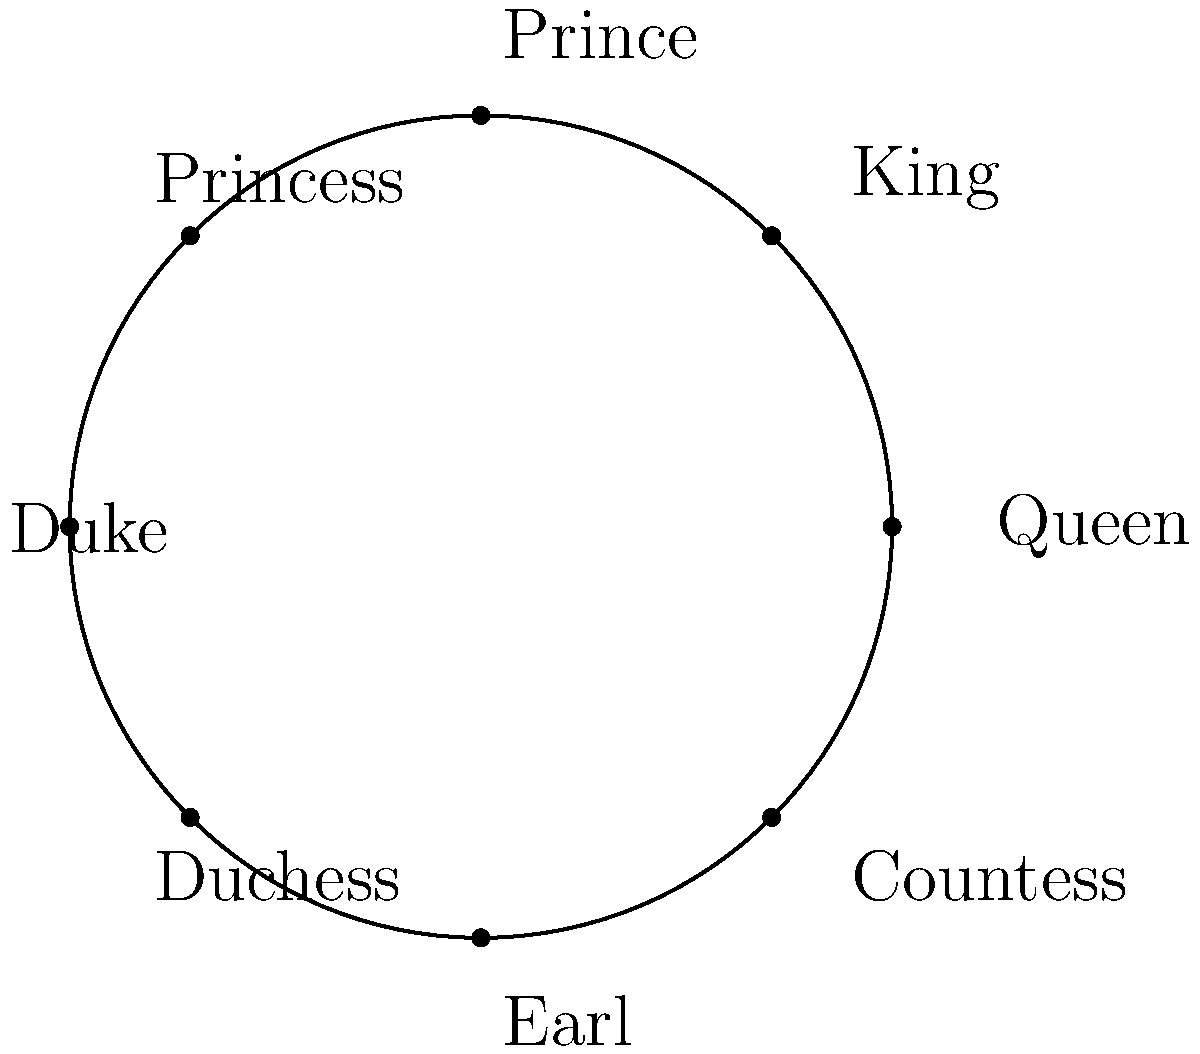At a royal banquet, guests are seated around a circular table as shown in the polar coordinate diagram. If the Queen is seated at $0°$ and the seating arrangement proceeds clockwise, at what angle would the Duchess be seated? To determine the angle at which the Duchess is seated, let's follow these steps:

1. Observe that the diagram shows 8 positions around the circle, each separated by 45°.
2. The seating arrangement proceeds clockwise from the Queen at 0°.
3. Count the positions clockwise from the Queen to the Duchess:
   - Queen (0°)
   - King (45°)
   - Prince (90°)
   - Princess (135°)
   - Duke (180°)
   - Duchess (next position)
4. The Duchess is in the 6th position from the Queen.
5. Calculate the angle: $6 \times 45° = 270°$

Therefore, the Duchess is seated at an angle of 270° in this polar coordinate system.
Answer: 270° 